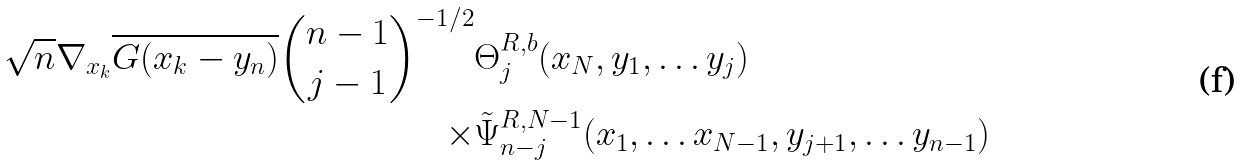Convert formula to latex. <formula><loc_0><loc_0><loc_500><loc_500>\sqrt { n } \nabla _ { x _ { k } } \overline { G ( x _ { k } - y _ { n } ) } { n - 1 \choose j - 1 } ^ { - 1 / 2 } & \Theta _ { j } ^ { R , b } ( x _ { N } , y _ { 1 } , \dots y _ { j } ) \\ \times & \tilde { \Psi } _ { n - j } ^ { R , N - 1 } ( x _ { 1 } , \dots x _ { N - 1 } , y _ { j + 1 } , \dots y _ { n - 1 } )</formula> 